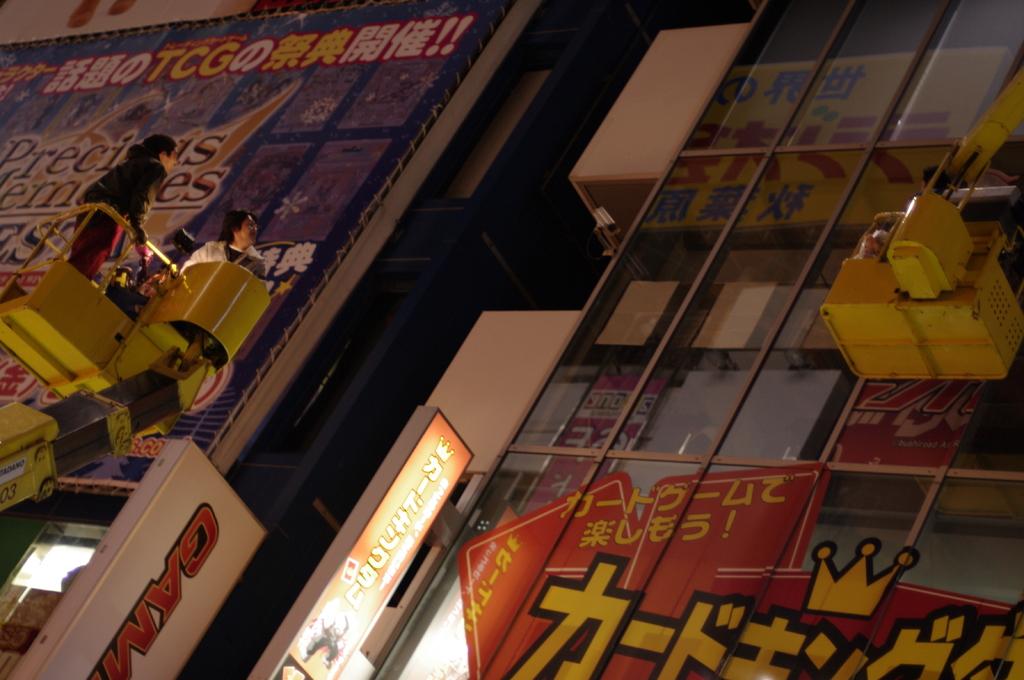What are the 2 numbers located on the bottom left on the bucket crane?
Give a very brief answer. 03. What three english letters are seen near the top left corner?
Offer a terse response. Tcg. 